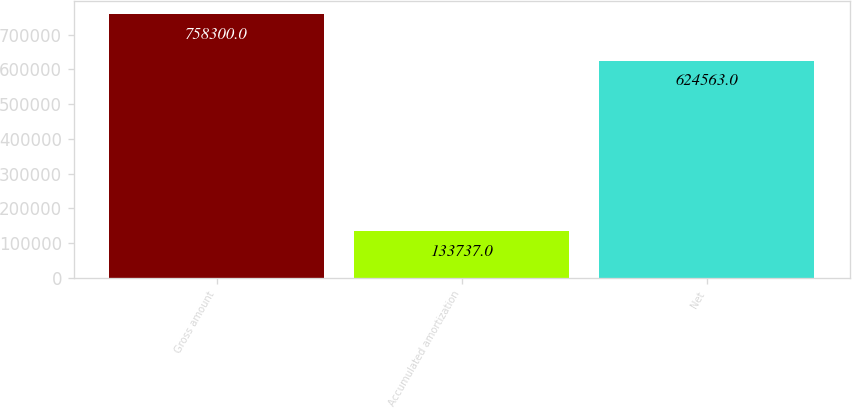<chart> <loc_0><loc_0><loc_500><loc_500><bar_chart><fcel>Gross amount<fcel>Accumulated amortization<fcel>Net<nl><fcel>758300<fcel>133737<fcel>624563<nl></chart> 